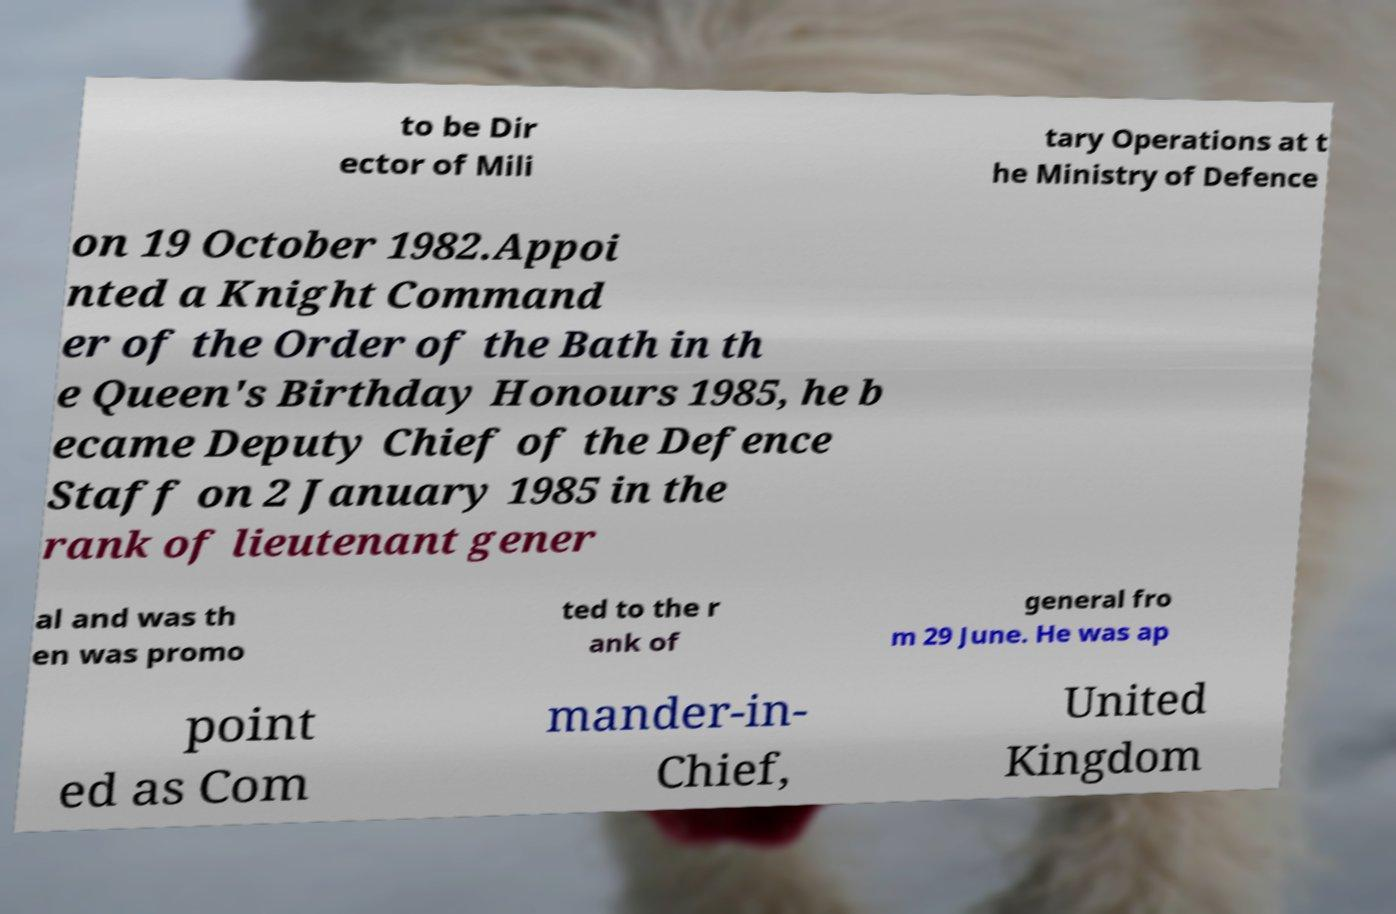Could you assist in decoding the text presented in this image and type it out clearly? to be Dir ector of Mili tary Operations at t he Ministry of Defence on 19 October 1982.Appoi nted a Knight Command er of the Order of the Bath in th e Queen's Birthday Honours 1985, he b ecame Deputy Chief of the Defence Staff on 2 January 1985 in the rank of lieutenant gener al and was th en was promo ted to the r ank of general fro m 29 June. He was ap point ed as Com mander-in- Chief, United Kingdom 